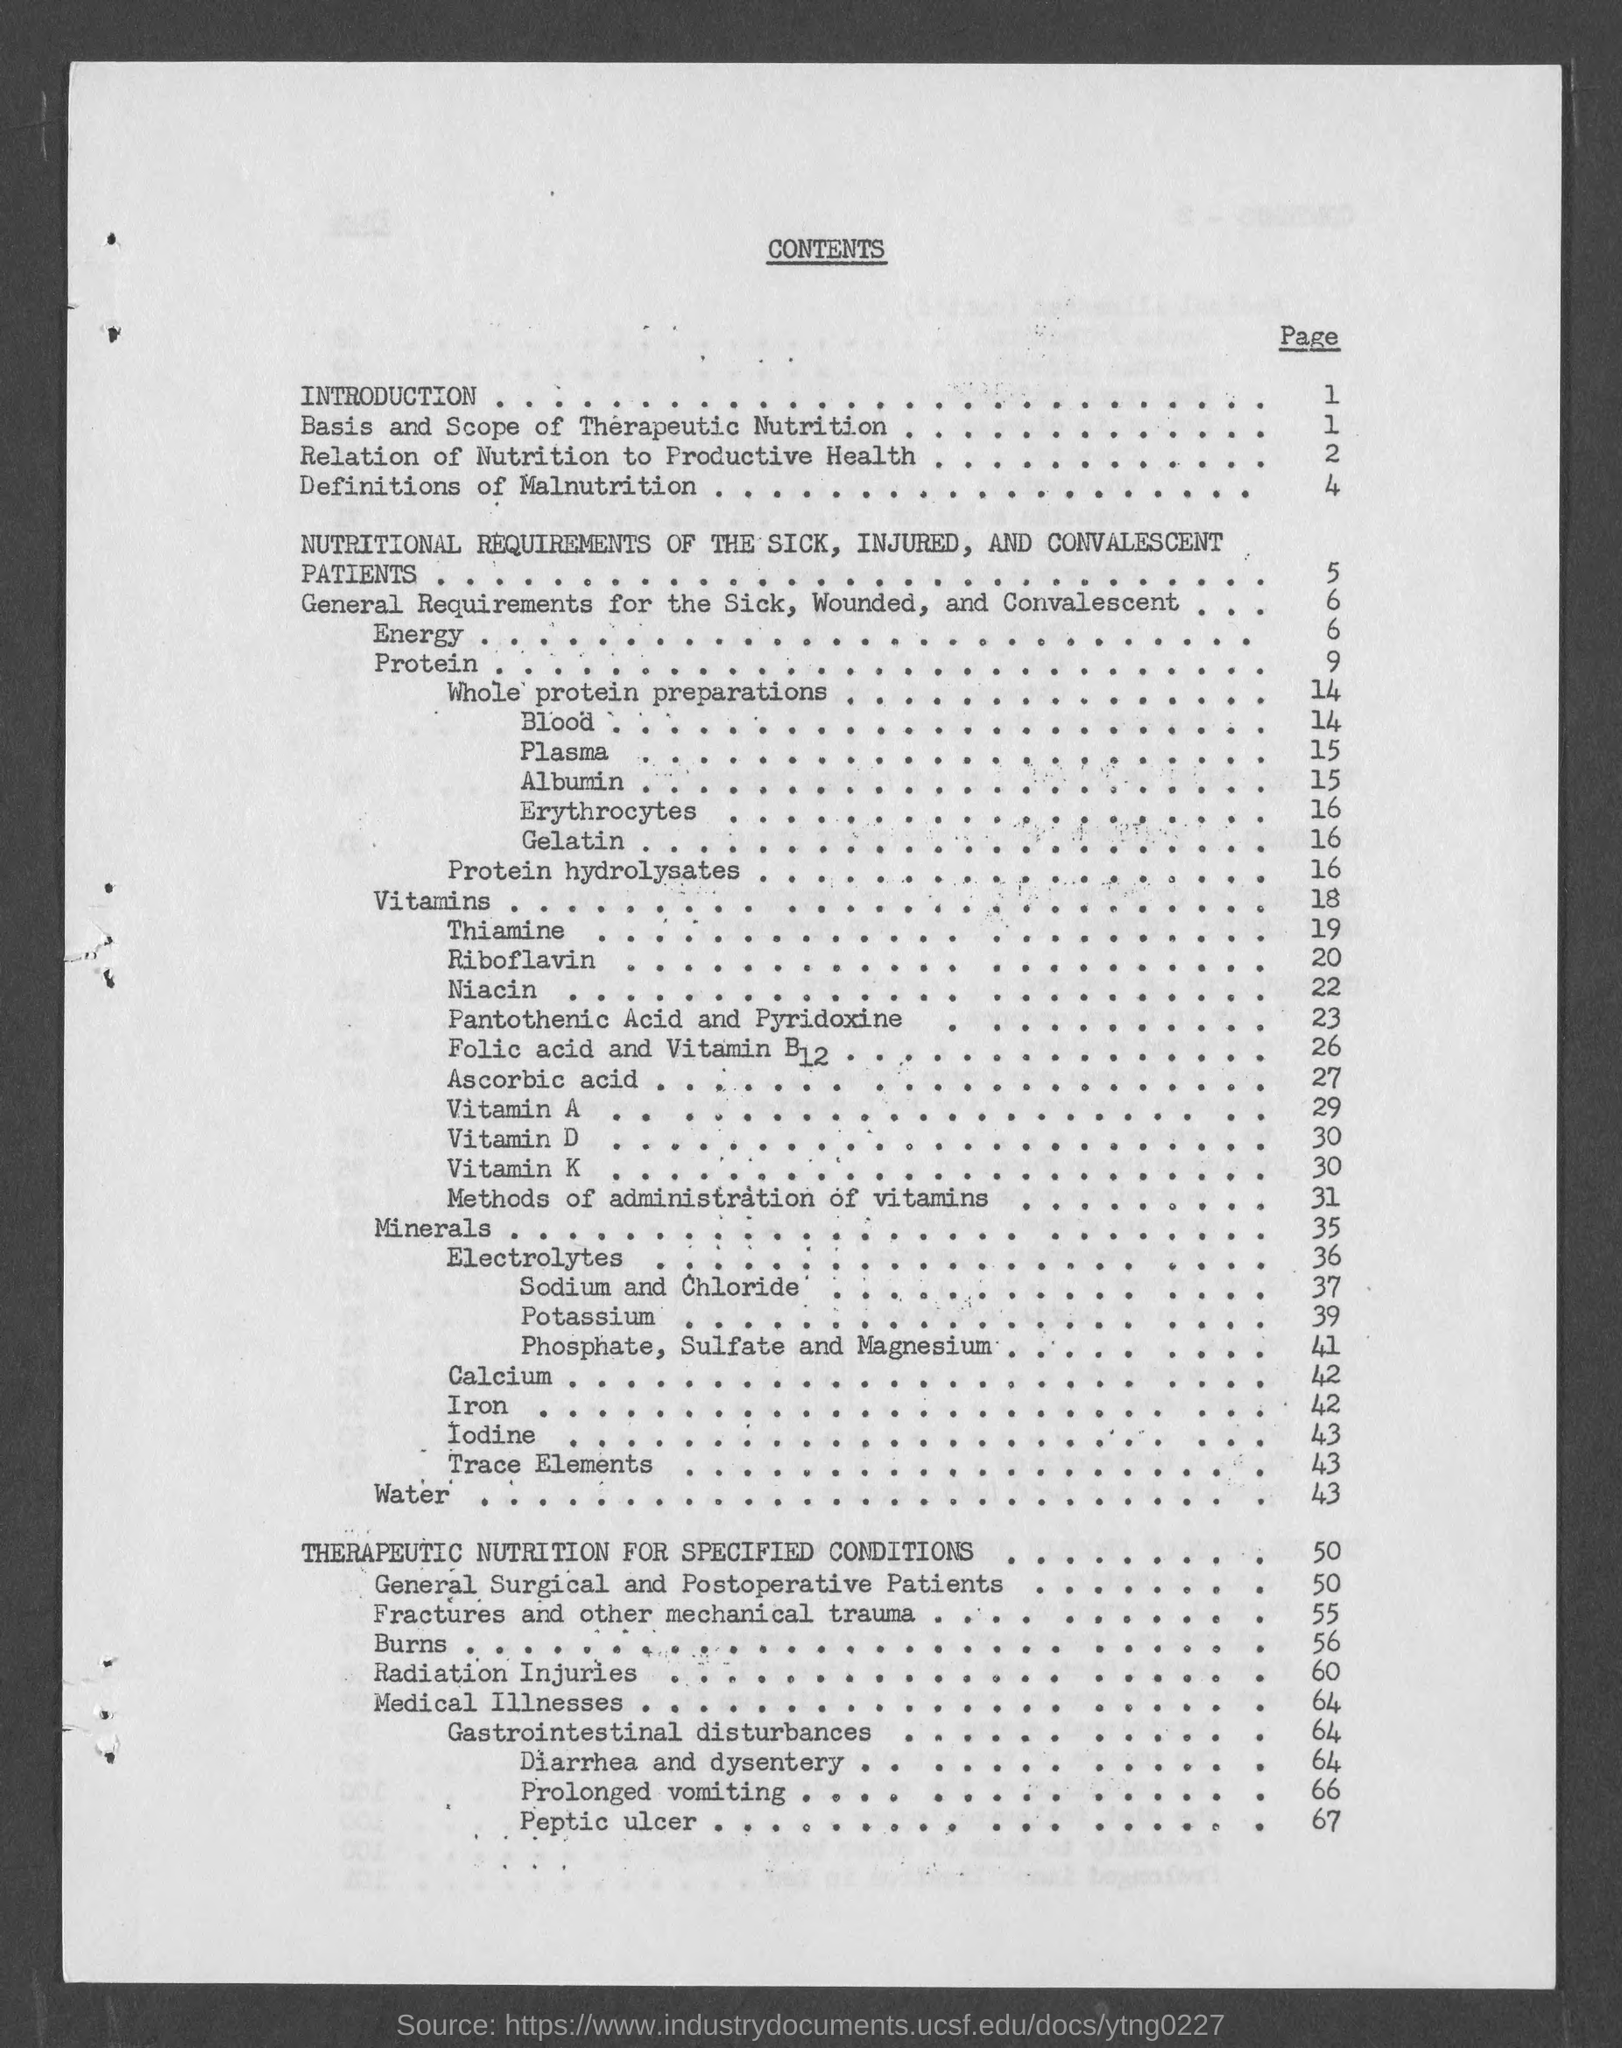What is the heading of the page ?
Your response must be concise. Contents. What is the page number for introduction ?
Offer a very short reply. 1. What is the page number for whole protein preparations ?
Your answer should be compact. 14. What is the page number for blood?
Offer a terse response. 14. What is the page number for plasma ?
Provide a succinct answer. 15. What is the page number for albumin ?
Keep it short and to the point. 15. What is the page number for erythrocytes ?
Offer a very short reply. 16. What is the page number for gelatin ?
Offer a very short reply. 16. What is the page number for peptic ulcer ?
Keep it short and to the point. 67. What is the page number for prolonged vomiting ?
Provide a succinct answer. 66. 